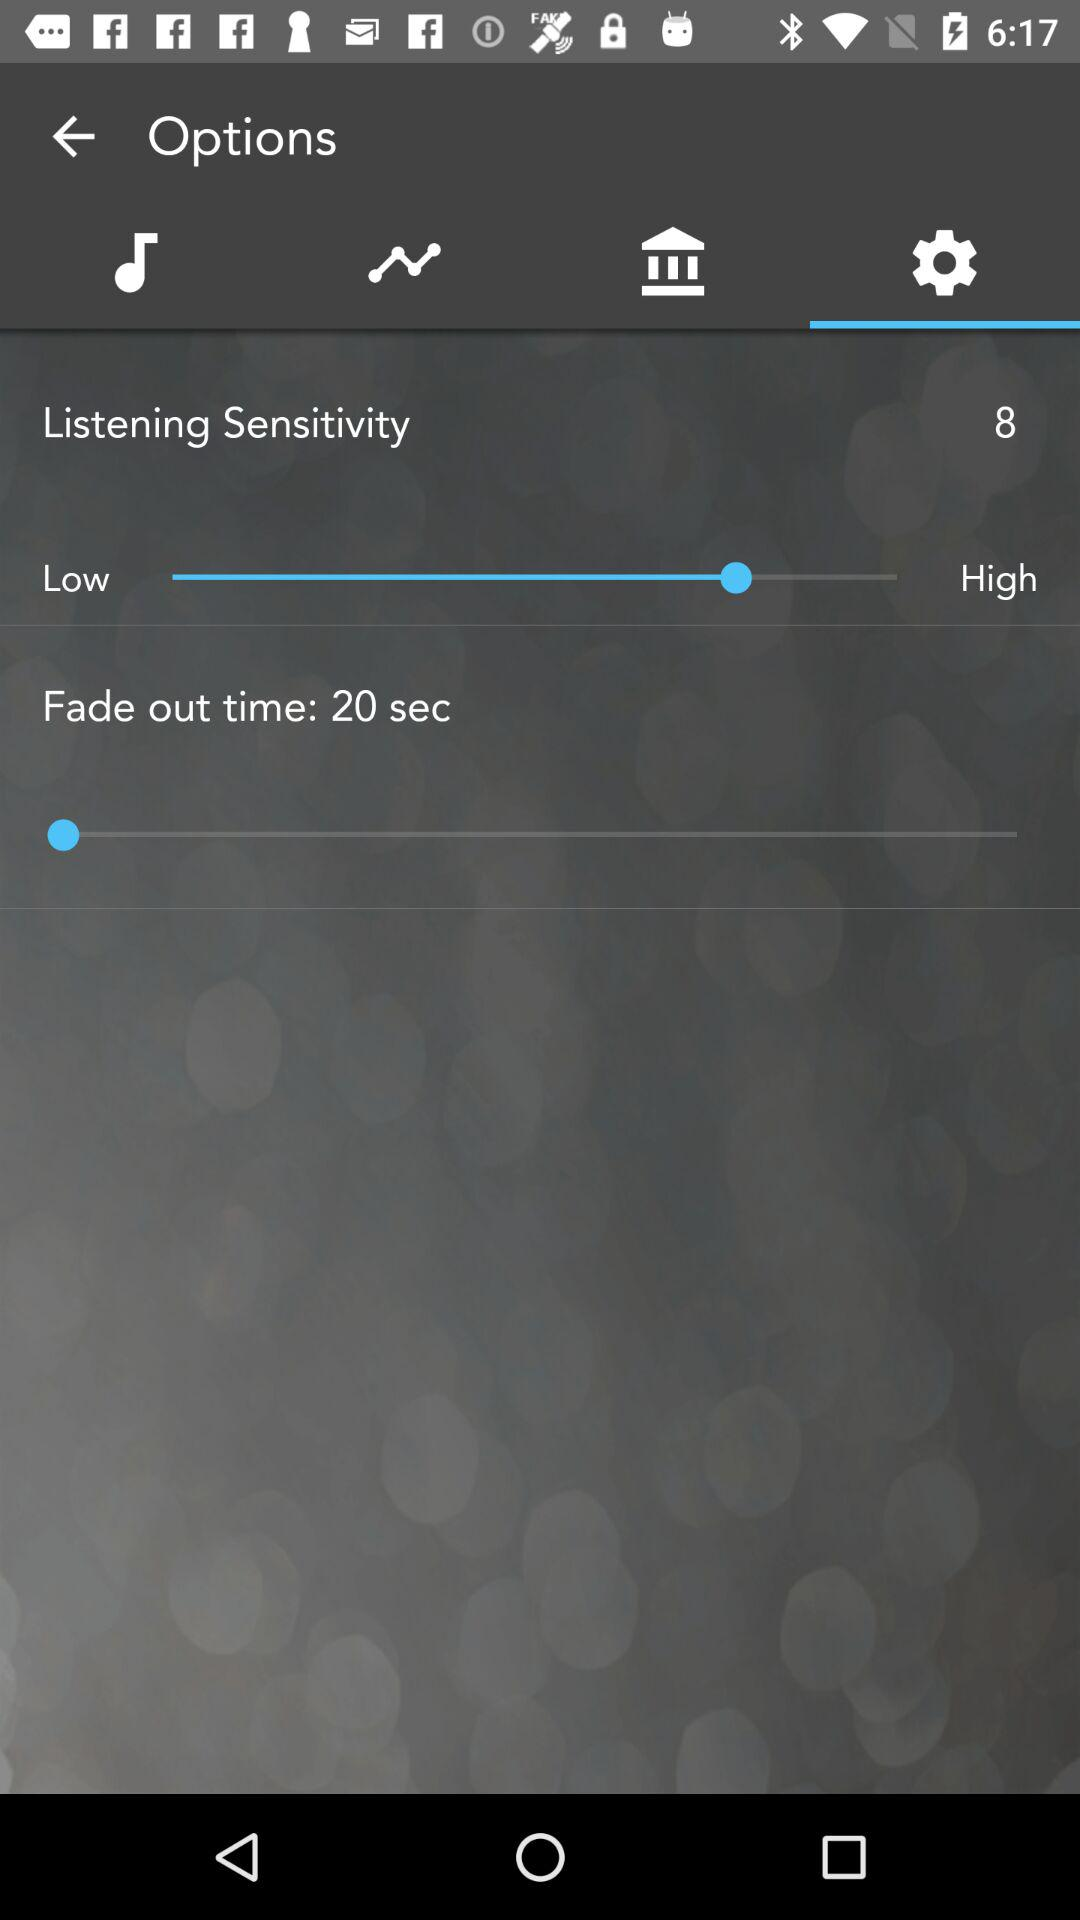What is the fade-out time? The fade-out time is 20 seconds. 